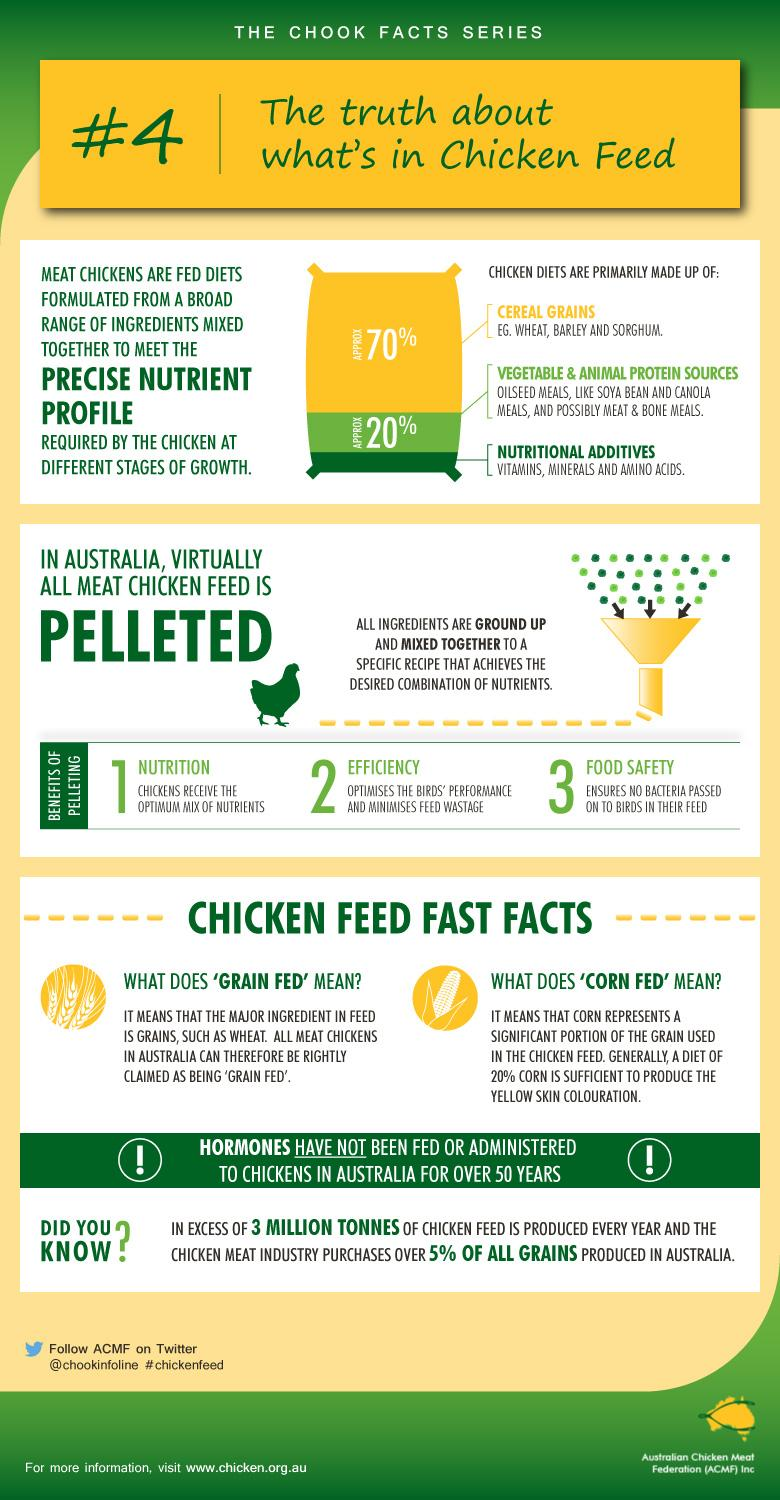Give some essential details in this illustration. Wheat, barley, and sorghum are common cereals used in the feed of chickens. Approximately 20% of the content of chicken diets is made up of vegetable and animal protein sources. In chicken diets, cereal grains make up approximately 70% of the total ingredients. Our chicken feed contains a balanced blend of vitamins, minerals, and amino acids to ensure that the chickens receive the necessary nutrients for optimal health and growth. Pelleting has been shown to significantly affect the nutrition of chickens, providing them with the optimal mix of essential nutrients for optimal growth and health. 